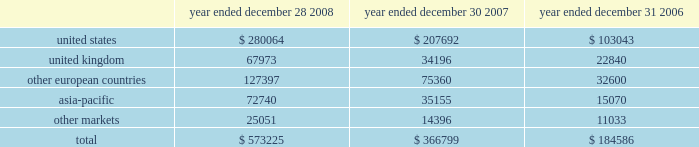Executive deferred compensation plan for the company 2019s executives and members of the board of directors , the company adopted the illumina , inc .
Deferred compensation plan ( the plan ) that became effective january 1 , 2008 .
Eligible participants can contribute up to 80% ( 80 % ) of their base salary and 100% ( 100 % ) of all other forms of compensation into the plan , including bonus , commission and director fees .
The company has agreed to credit the participants 2019 contributions with earnings that reflect the performance of certain independent investment funds .
On a discretionary basis , the company may also make employer contributions to participant accounts in any amount determined by the company .
The vesting schedules of employer contributions are at the sole discretion of the compensation committee .
However , all employer contributions shall become 100% ( 100 % ) vested upon the occurrence of the participant 2019s disability , death or retirement or a change in control of the company .
The benefits under this plan are unsecured .
Participants are generally eligible to receive payment of their vested benefit at the end of their elected deferral period or after termination of their employment with the company for any reason or at a later date to comply with the restrictions of section 409a .
As of december 28 , 2008 , no employer contributions were made to the plan .
In january 2008 , the company also established a rabbi trust for the benefit of its directors and executives under the plan .
In accordance with fasb interpretation ( fin ) no .
46 , consolidation of variable interest entities , an interpretation of arb no .
51 , and eitf 97-14 , accounting for deferred compensation arrangements where amounts earned are held in a rabbi trust and invested , the company has included the assets of the rabbi trust in its consolidated balance sheet since the trust 2019s inception .
As of december 28 , 2008 , the assets of the trust and liabilities of the company were $ 1.3 million .
The assets and liabilities are classified as other assets and accrued liabilities , respectively , on the company 2019s balance sheet as of december 28 , 2008 .
Changes in the values of the assets held by the rabbi trust accrue to the company .
14 .
Segment information , geographic data and significant customers during the first quarter of 2008 , the company reorganized its operating structure into a newly created life sciences business unit , which includes all products and services related to the research market , namely the beadarray , beadxpress and sequencing product lines .
The company also created a diagnostics business unit to focus on the emerging opportunity in molecular diagnostics .
For the year ended december 28 , 2008 , the company had limited activity related to the diagnostics business unit , and operating results were reported on an aggregate basis to the chief operating decision maker of the company , the chief executive officer .
In accordance with sfas no .
131 , disclosures about segments of an enterprise and related information , the company operated in one reportable segment for the year ended december 28 , 2008 .
The company had revenue in the following regions for the years ended december 28 , 2008 , december 30 , 2007 and december 31 , 2006 ( in thousands ) : year ended december 28 , year ended december 30 , year ended december 31 .
Net revenues are attributable to geographic areas based on the region of destination .
Illumina , inc .
Notes to consolidated financial statements 2014 ( continued ) .
For the year ended december 28 , 2008 what was the ratio of the united states to the united kingdom revenues? 
Rationale: for the year ended december 28 , 2008 there was $ 4.12 in united states revenues to the united kingdom
Computations: (280064 / 67973)
Answer: 4.12022. 